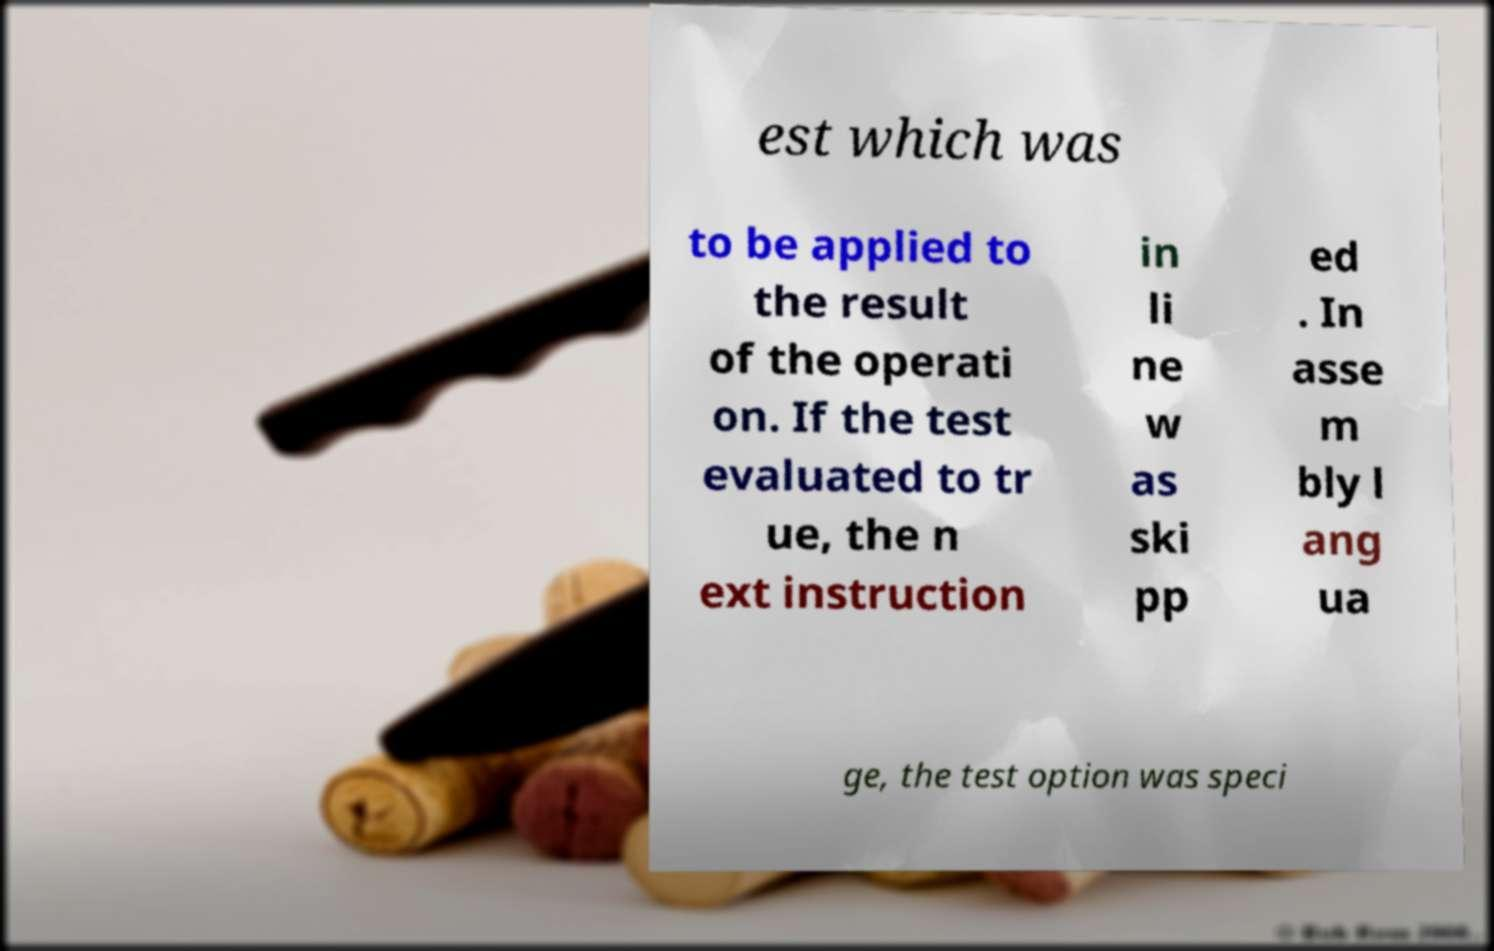I need the written content from this picture converted into text. Can you do that? est which was to be applied to the result of the operati on. If the test evaluated to tr ue, the n ext instruction in li ne w as ski pp ed . In asse m bly l ang ua ge, the test option was speci 